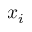<formula> <loc_0><loc_0><loc_500><loc_500>x _ { i }</formula> 